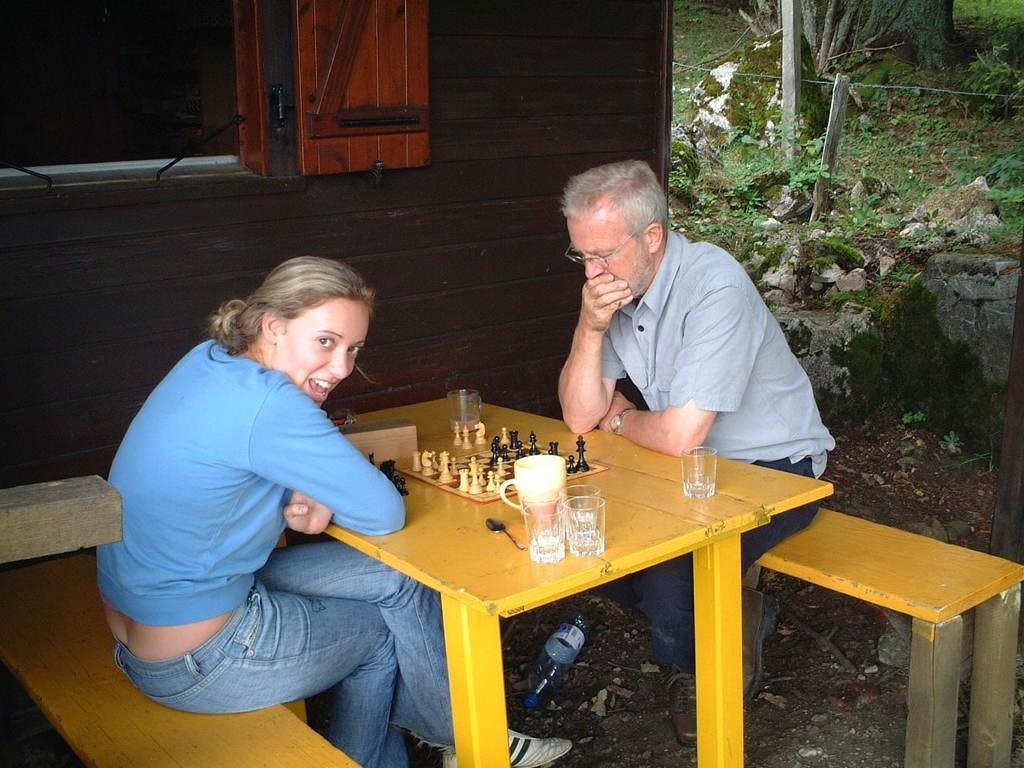Can you describe this image briefly? In the given image we can see two people are playing chess. There is a water bottle, on a table there is a glass and a spoon. 